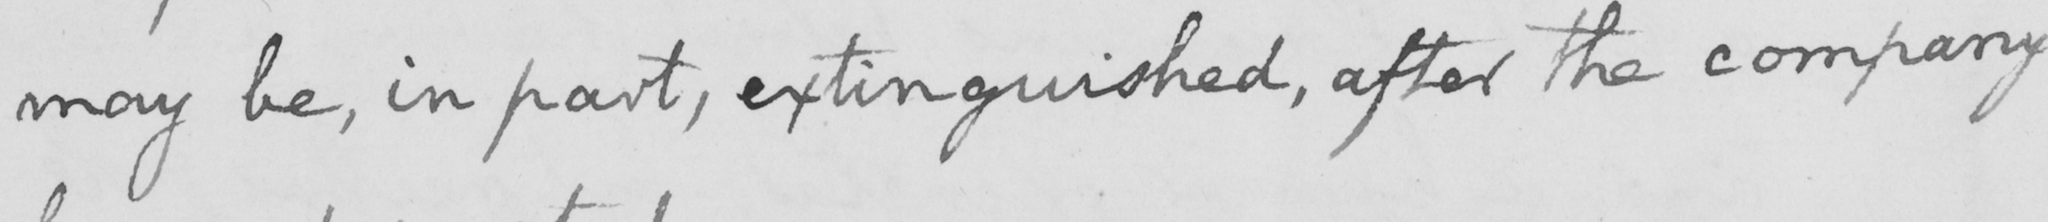Can you tell me what this handwritten text says? may be , in part , extinguished , after the company 